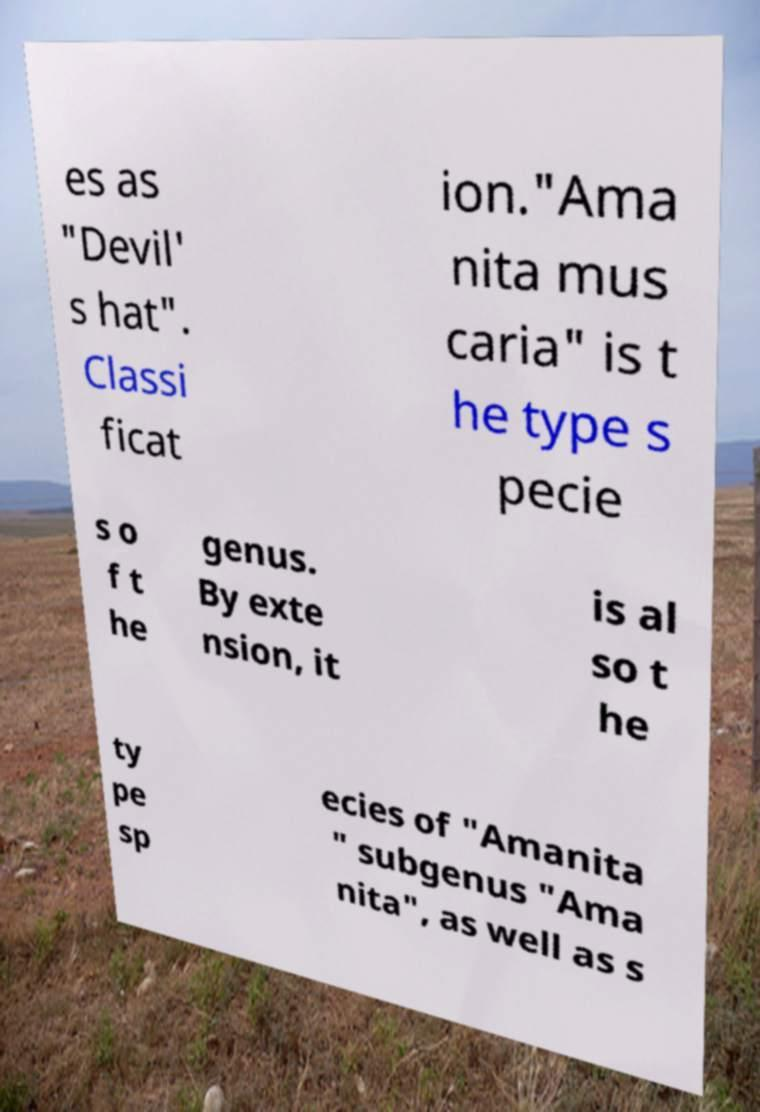Could you extract and type out the text from this image? es as "Devil' s hat". Classi ficat ion."Ama nita mus caria" is t he type s pecie s o f t he genus. By exte nsion, it is al so t he ty pe sp ecies of "Amanita " subgenus "Ama nita", as well as s 